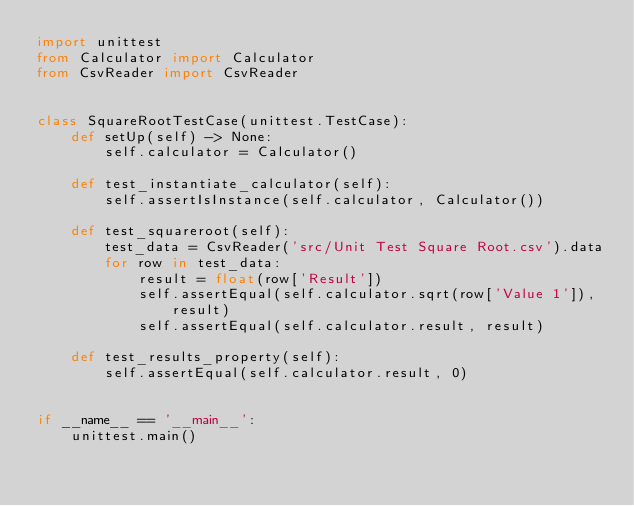Convert code to text. <code><loc_0><loc_0><loc_500><loc_500><_Python_>import unittest
from Calculator import Calculator
from CsvReader import CsvReader


class SquareRootTestCase(unittest.TestCase):
    def setUp(self) -> None:
        self.calculator = Calculator()

    def test_instantiate_calculator(self):
        self.assertIsInstance(self.calculator, Calculator())

    def test_squareroot(self):
        test_data = CsvReader('src/Unit Test Square Root.csv').data
        for row in test_data:
            result = float(row['Result'])
            self.assertEqual(self.calculator.sqrt(row['Value 1']), result)
            self.assertEqual(self.calculator.result, result)

    def test_results_property(self):
        self.assertEqual(self.calculator.result, 0)


if __name__ == '__main__':
    unittest.main()</code> 